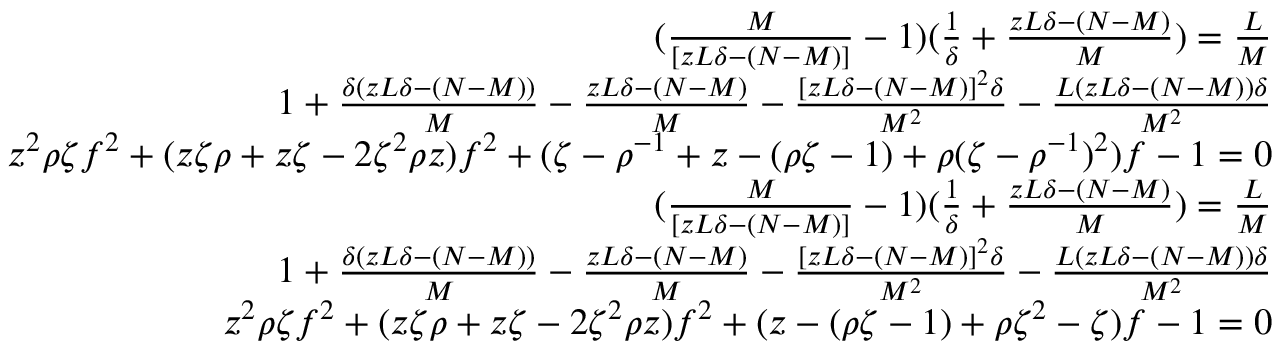<formula> <loc_0><loc_0><loc_500><loc_500>\begin{array} { r } { ( \frac { M } { [ z L \delta - ( N - M ) ] } - 1 ) ( \frac { 1 } { \delta } + \frac { z L \delta - ( N - M ) } { M } ) = \frac { L } { M } } \\ { 1 + \frac { \delta ( z L \delta - ( N - M ) ) } { M } - \frac { z L \delta - ( N - M ) } { M } - \frac { [ z L \delta - ( N - M ) ] ^ { 2 } \delta } { M ^ { 2 } } - \frac { L ( z L \delta - ( N - M ) ) \delta } { M ^ { 2 } } } \\ { z ^ { 2 } \rho \zeta f ^ { 2 } + ( z \zeta \rho + z \zeta - 2 \zeta ^ { 2 } \rho z ) f ^ { 2 } + ( \zeta - \rho ^ { - 1 } + z - ( \rho \zeta - 1 ) + \rho ( \zeta - \rho ^ { - 1 } ) ^ { 2 } ) f - 1 = 0 } \\ { ( \frac { M } { [ z L \delta - ( N - M ) ] } - 1 ) ( \frac { 1 } { \delta } + \frac { z L \delta - ( N - M ) } { M } ) = \frac { L } { M } } \\ { 1 + \frac { \delta ( z L \delta - ( N - M ) ) } { M } - \frac { z L \delta - ( N - M ) } { M } - \frac { [ z L \delta - ( N - M ) ] ^ { 2 } \delta } { M ^ { 2 } } - \frac { L ( z L \delta - ( N - M ) ) \delta } { M ^ { 2 } } } \\ { z ^ { 2 } \rho \zeta f ^ { 2 } + ( z \zeta \rho + z \zeta - 2 \zeta ^ { 2 } \rho z ) f ^ { 2 } + ( z - ( \rho \zeta - 1 ) + \rho \zeta ^ { 2 } - \zeta ) f - 1 = 0 } \end{array}</formula> 